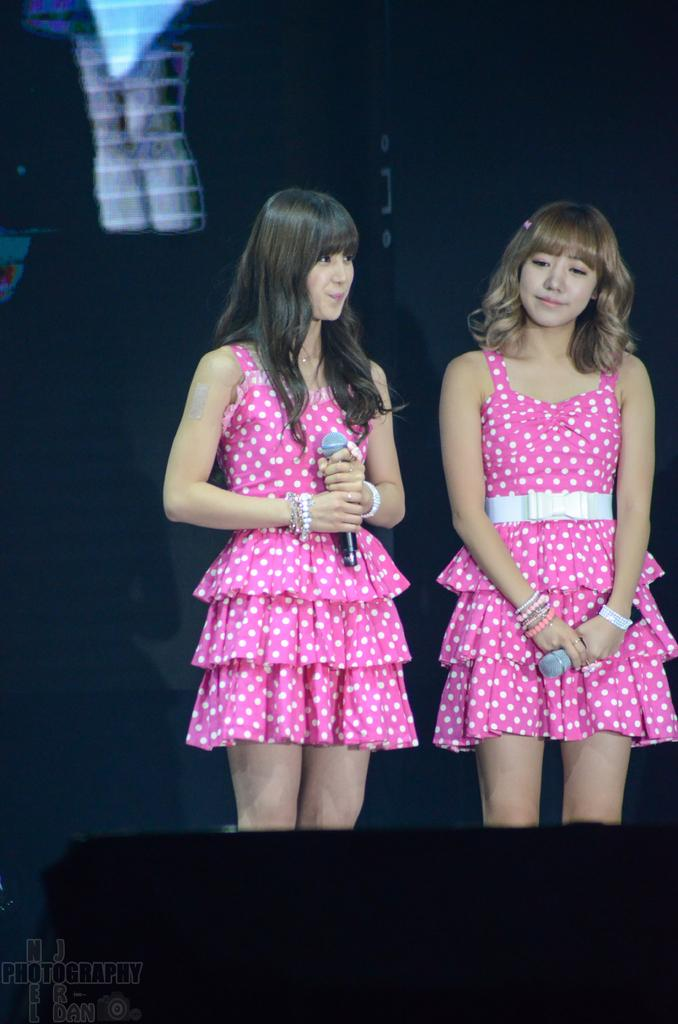How many people are in the image? There are two persons in the image. What are the persons doing in the image? The persons are standing in the image. What are the persons wearing? The persons are wearing clothes in the image. What objects are the persons holding in their hands? The persons are holding mics in their hands in the image. What type of orange can be seen in the image? There is no orange present in the image. What subject is being taught in the class depicted in the image? There is no class depicted in the image. 